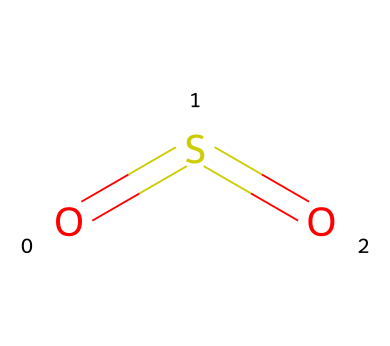What is the name of this chemical? The chemical represented by the SMILES O=S=O is commonly known as sulfur dioxide.
Answer: sulfur dioxide How many oxygen atoms are present? The SMILES notation O=S=O indicates there are two oxygen atoms bonded to the sulfur atom.
Answer: two How many bonds exist in the structure? In the structure, there are two double bonds: one between sulfur and each oxygen atom. Therefore, there are two bonds in total.
Answer: two What is the oxidation state of sulfur in this compound? In sulfur dioxide, sulfur has an oxidation state of +4 based on its bonding with the oxygen atoms.
Answer: +4 What type of pollutant is sulfur dioxide classified as? Sulfur dioxide is classified as a primary air pollutant due to its direct emission from sources like burning fossil fuels.
Answer: primary air pollutant What impact does sulfur dioxide have on the environment? Sulfur dioxide contributes to the formation of acid rain, which can harm ecosystems, buildings, and human health.
Answer: acid rain What is the molecular geometry around the sulfur atom? The molecular geometry around the sulfur atom in sulfur dioxide is bent due to the two bonded oxygen atoms and the lone pair on sulfur.
Answer: bent 